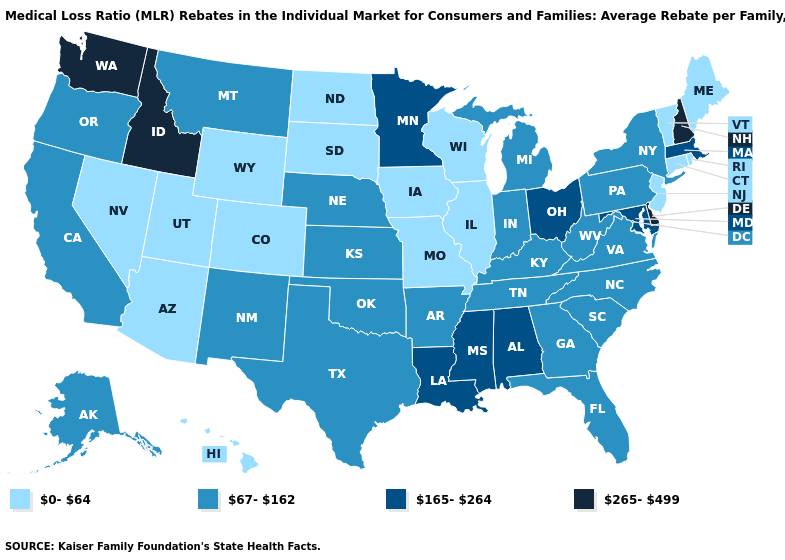Does the map have missing data?
Be succinct. No. Does New York have the lowest value in the USA?
Give a very brief answer. No. Among the states that border Texas , which have the lowest value?
Answer briefly. Arkansas, New Mexico, Oklahoma. Does Florida have the lowest value in the South?
Answer briefly. Yes. Does Maryland have a lower value than New Hampshire?
Answer briefly. Yes. What is the lowest value in states that border Missouri?
Quick response, please. 0-64. Name the states that have a value in the range 67-162?
Answer briefly. Alaska, Arkansas, California, Florida, Georgia, Indiana, Kansas, Kentucky, Michigan, Montana, Nebraska, New Mexico, New York, North Carolina, Oklahoma, Oregon, Pennsylvania, South Carolina, Tennessee, Texas, Virginia, West Virginia. Does California have a lower value than Louisiana?
Short answer required. Yes. What is the value of Kentucky?
Quick response, please. 67-162. Is the legend a continuous bar?
Short answer required. No. Among the states that border Ohio , which have the highest value?
Quick response, please. Indiana, Kentucky, Michigan, Pennsylvania, West Virginia. What is the lowest value in the USA?
Short answer required. 0-64. Which states hav the highest value in the West?
Keep it brief. Idaho, Washington. Does the first symbol in the legend represent the smallest category?
Give a very brief answer. Yes. What is the highest value in the USA?
Keep it brief. 265-499. 